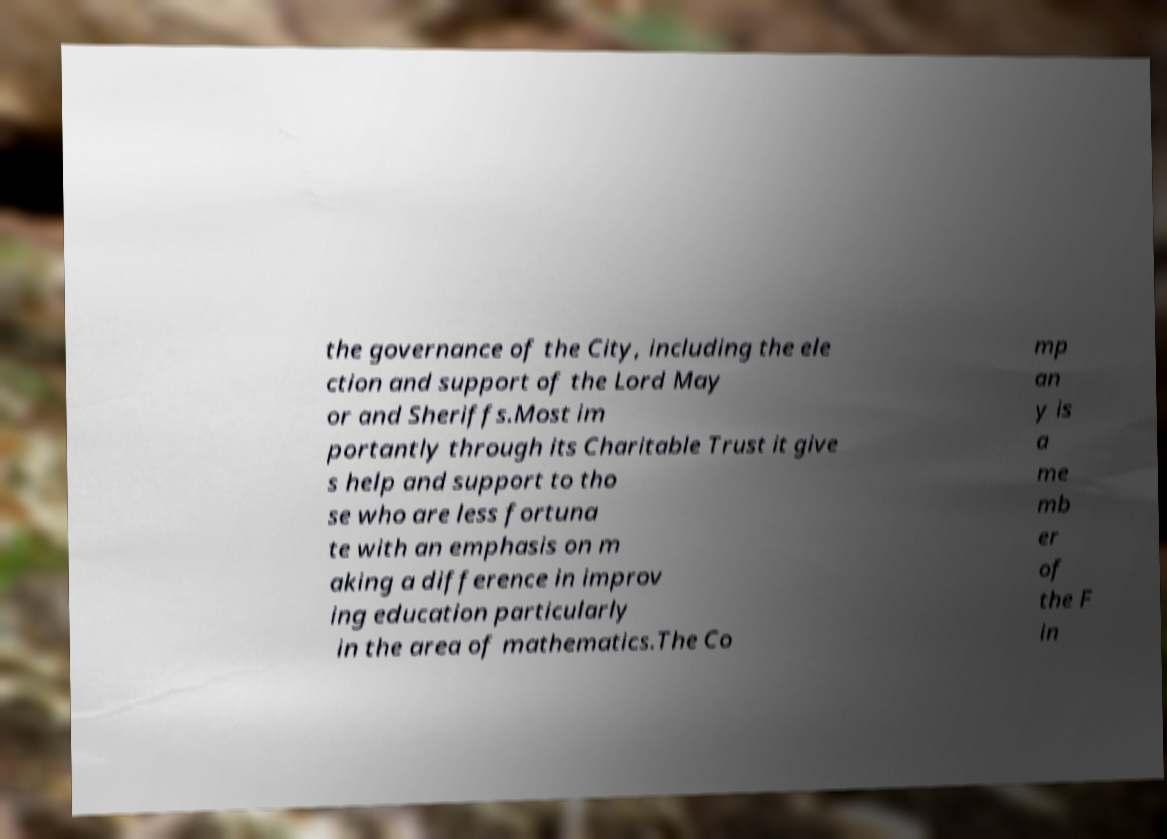What messages or text are displayed in this image? I need them in a readable, typed format. the governance of the City, including the ele ction and support of the Lord May or and Sheriffs.Most im portantly through its Charitable Trust it give s help and support to tho se who are less fortuna te with an emphasis on m aking a difference in improv ing education particularly in the area of mathematics.The Co mp an y is a me mb er of the F in 